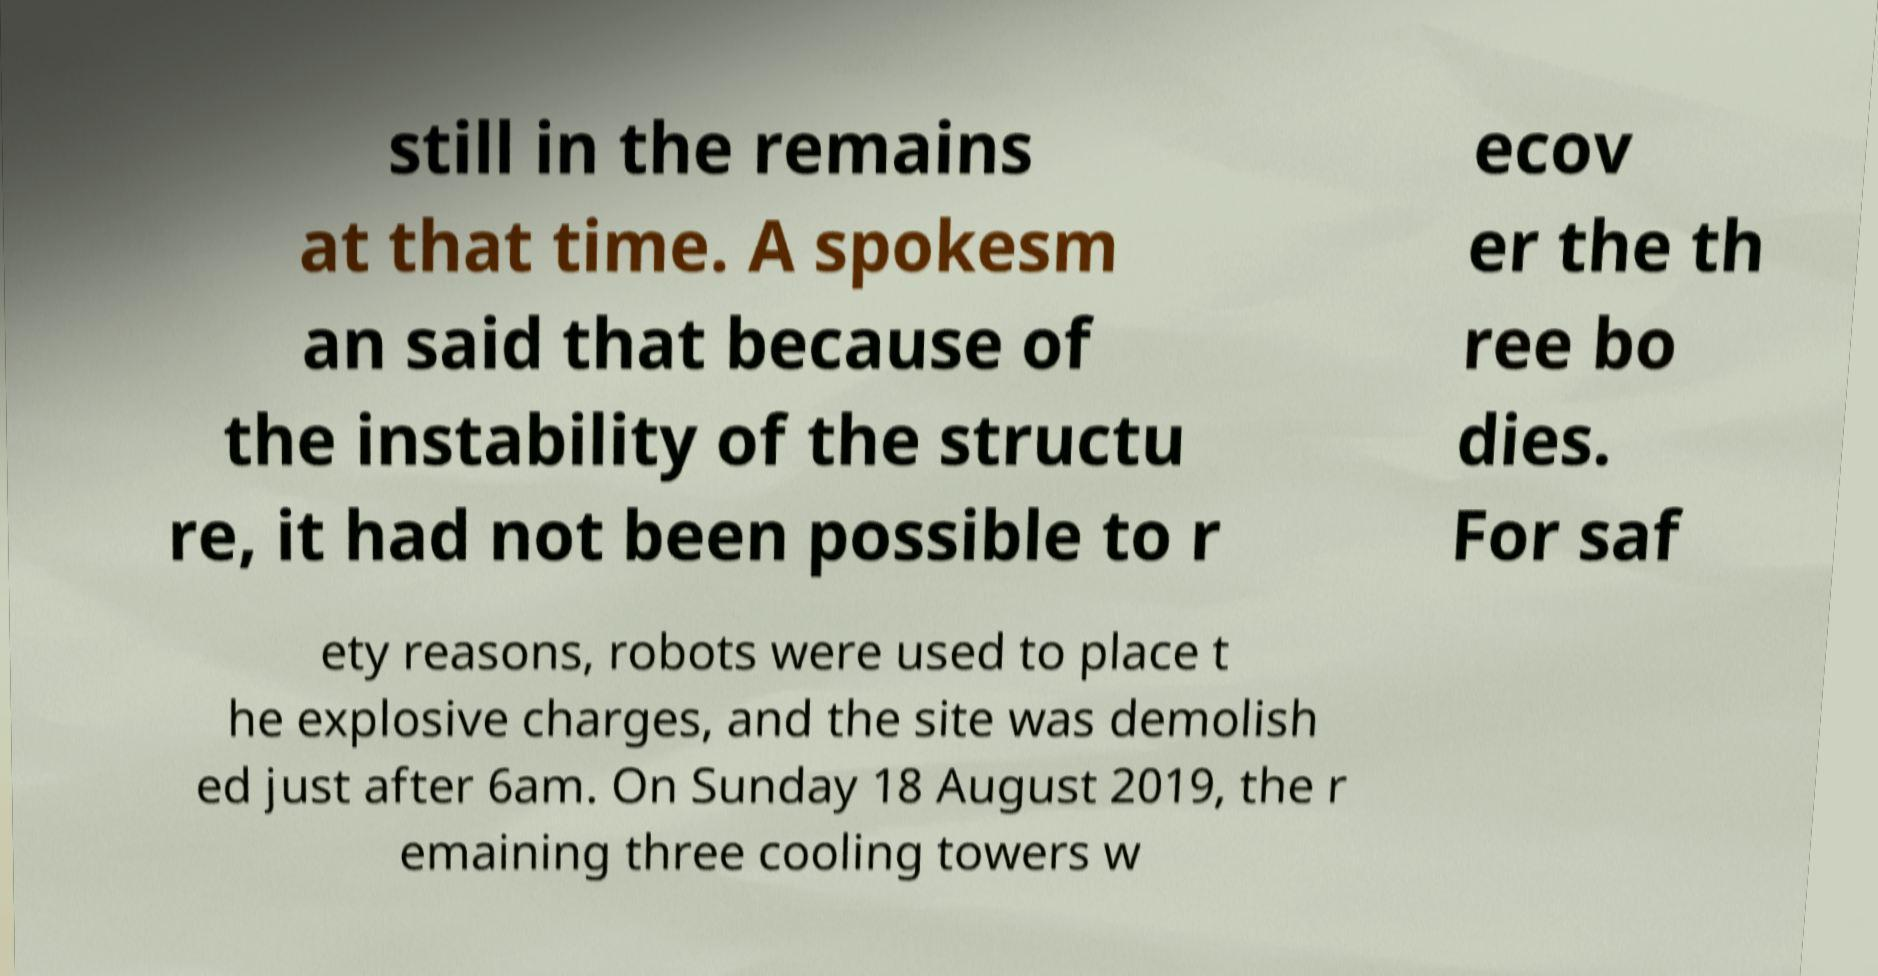Can you accurately transcribe the text from the provided image for me? still in the remains at that time. A spokesm an said that because of the instability of the structu re, it had not been possible to r ecov er the th ree bo dies. For saf ety reasons, robots were used to place t he explosive charges, and the site was demolish ed just after 6am. On Sunday 18 August 2019, the r emaining three cooling towers w 